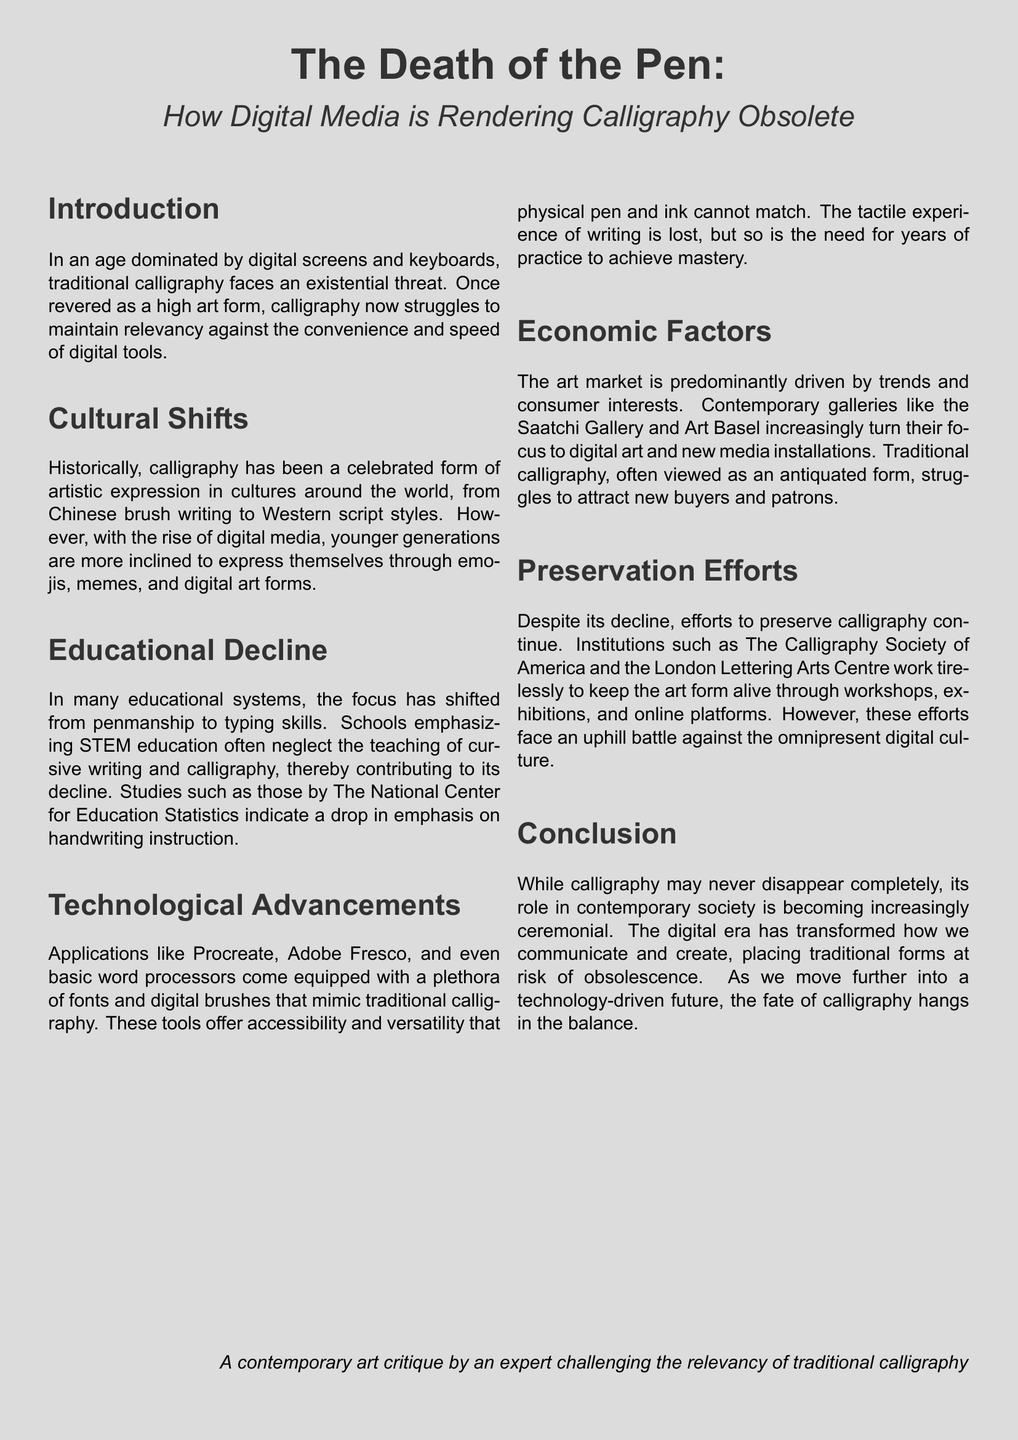What is the title of the flyer? The title is prominently displayed at the top of the document.
Answer: The Death of the Pen: How Digital Media is Rendering Calligraphy Obsolete What is the primary concern addressed in the introduction? The introduction highlights the existential threat to traditional calligraphy in the digital age.
Answer: Existential threat What has been a cultural shift influencing calligraphy? The document mentions younger generations preferring new forms of expression.
Answer: Digital art forms Which educational focus has contributed to the decline of calligraphy? It states that schools are emphasizing typing skills over penmanship.
Answer: Typing skills Name one application that mimics traditional calligraphy. The document lists applications that provide digital alternatives to calligraphy.
Answer: Procreate What are contemporary galleries increasingly focusing on? The document notes the shift toward different art forms within the art market.
Answer: Digital art What efforts exist to preserve calligraphy? The document mentions institutions working to keep the art form alive.
Answer: Workshops What future role does the conclusion suggest calligraphy will have? The conclusion speculates on the diminishing presence of calligraphy in everyday use.
Answer: Ceremonial How does technological advancement impact the practice of calligraphy? The document discusses the accessibility and lost mastery due to technology.
Answer: Accessibility and versatility 